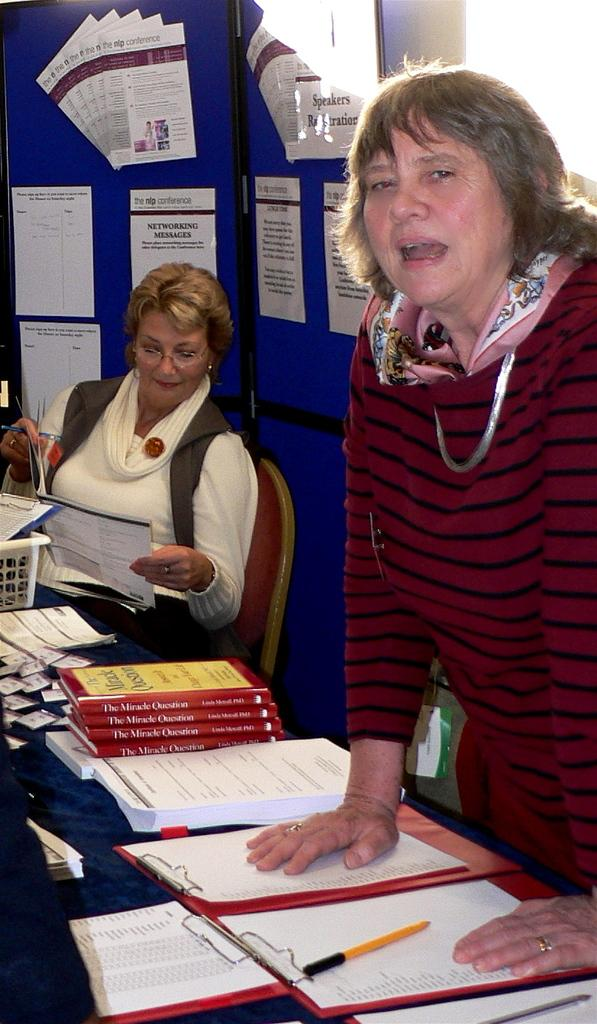Provide a one-sentence caption for the provided image. Two women work the registration table for the nip Conference. 